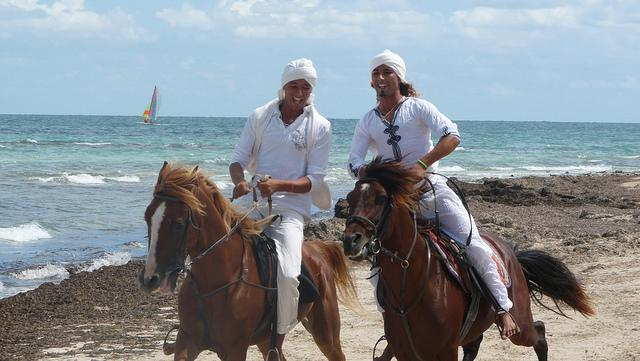Why are they so close together? Please explain your reasoning. to talk. The men look like they are friends. 